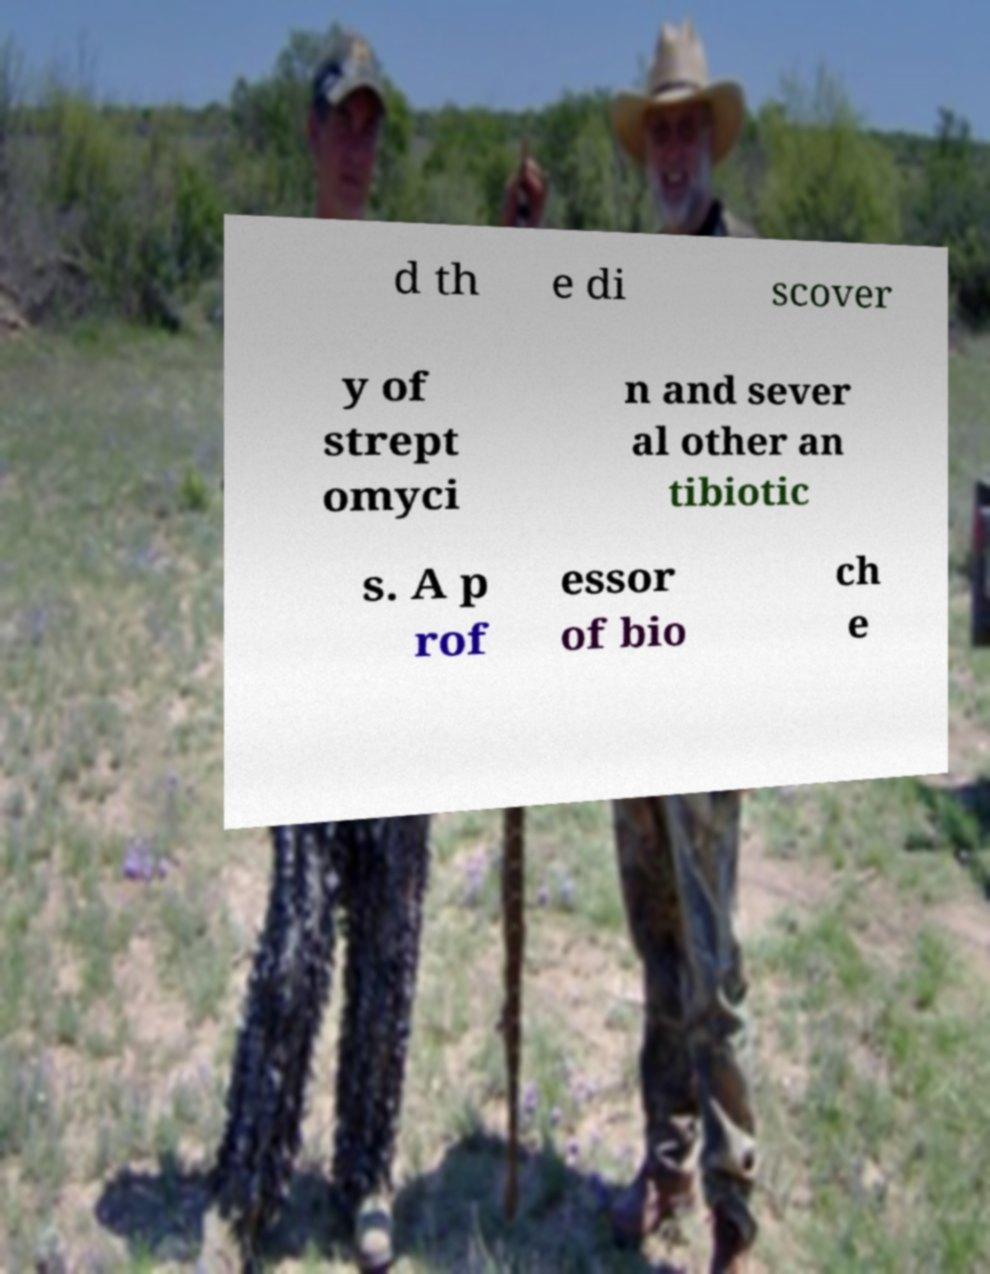Could you extract and type out the text from this image? d th e di scover y of strept omyci n and sever al other an tibiotic s. A p rof essor of bio ch e 